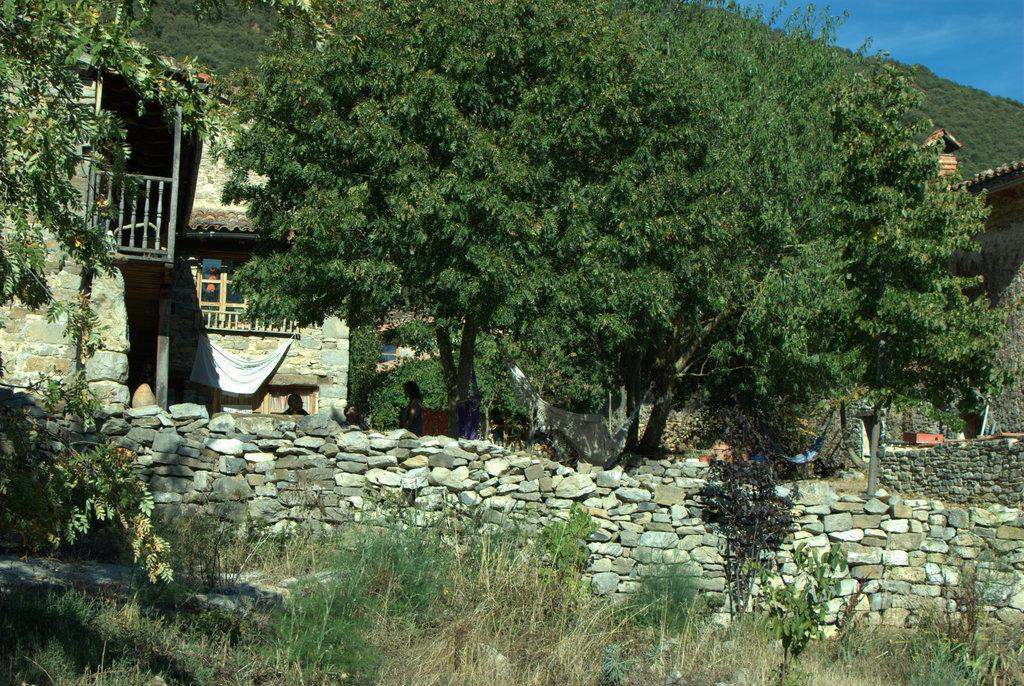What type of natural elements can be seen in the image? There are trees in the image. What type of man-made structures can be seen in the image? There are buildings in the image. What type of objects can be seen on the ground in the image? There are stones in the image. Are there any living beings present in the image? Yes, there are people in the image. What can be seen in the background of the image? The sky is visible in the background of the image. Is there a river flowing through the image? No, there is no river present in the image. Are there any signs of a protest taking place in the image? No, there is no indication of a protest in the image. 